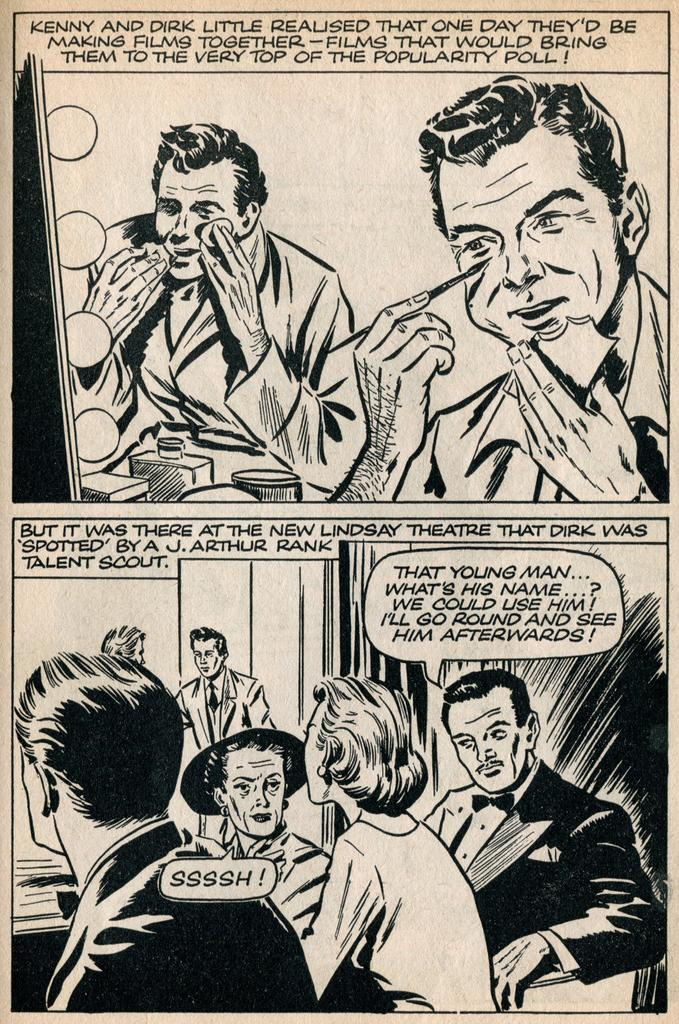Provide a one-sentence caption for the provided image. A comic book illustration featuring men putting on making and a woman saying SSSH. 